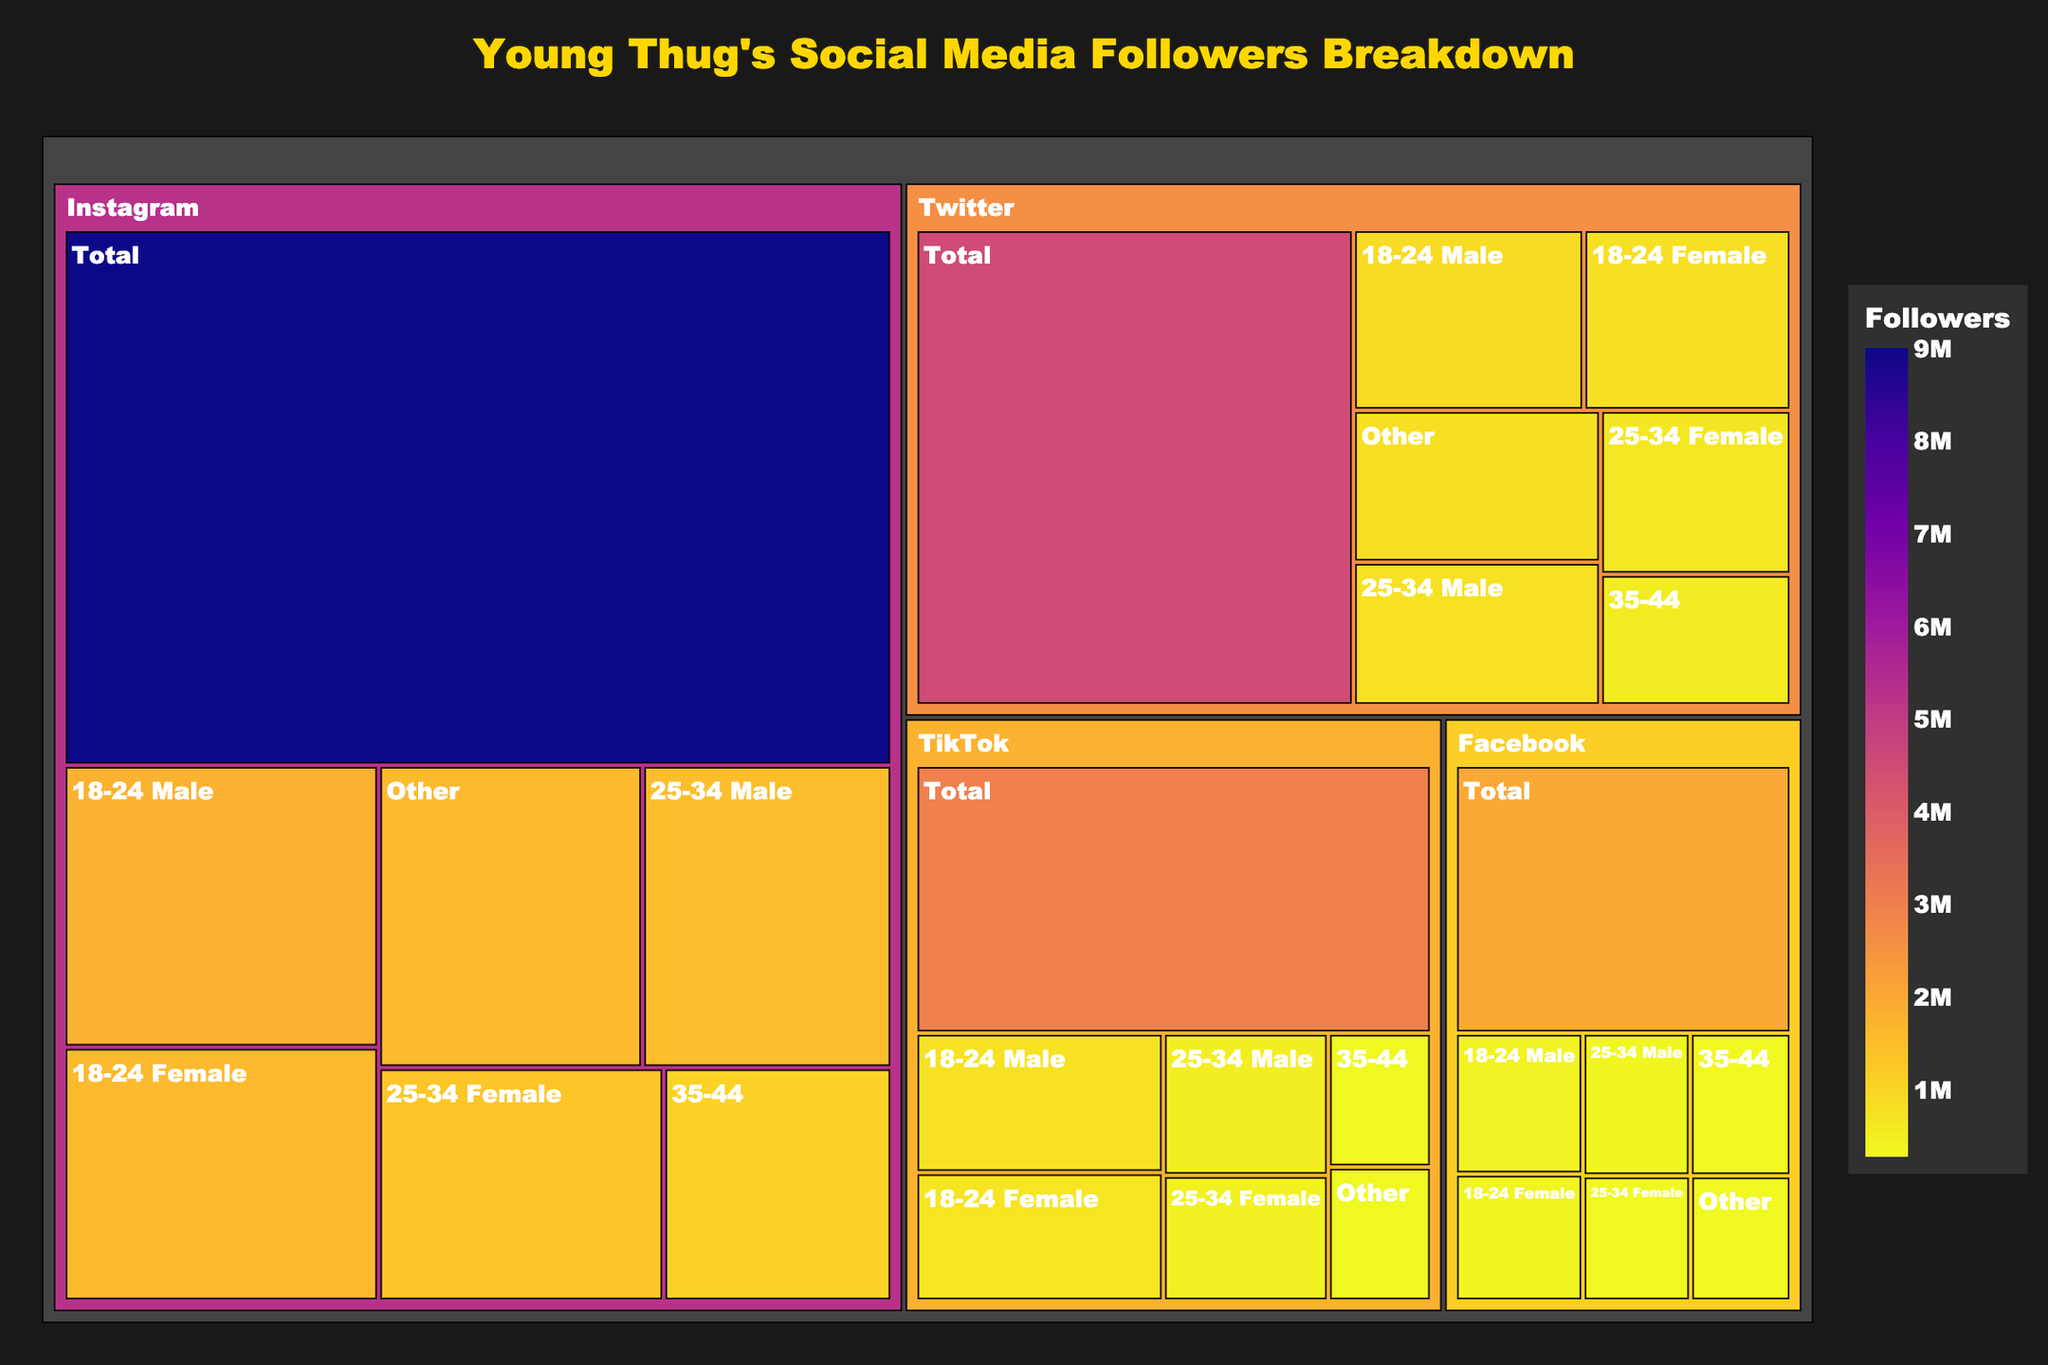What's the total number of followers on Instagram? The treemap shows a category for total followers on each platform. Find the "Instagram" category and look for the "Total" subcategory, which displays 9,000,000 followers.
Answer: 9 million What's the number of followers in the 25-34 Female category on TikTok? Locate the TikTok category in the treemap, then find the "25-34 Female" subcategory, which displays 450,000 followers.
Answer: 450,000 How many more followers does Instagram have compared to Facebook? Instagram's total followers: 9,000,000. Facebook's total followers: 2,000,000. Subtract Facebook's total from Instagram's total: 9,000,000 - 2,000,000 = 7,000,000.
Answer: 7 million Which platform has the fewest total followers? Examine the total follower counts for all platforms. Facebook has the fewest with 2,000,000 followers.
Answer: Facebook What is the combined number of Twitter followers in the 25-34 age range? Twitter's followers for 25-34 Male: 765,000. Twitter's followers for 25-34 Female: 675,000. Add these two numbers: 765,000 + 675,000 = 1,440,000.
Answer: 1.44 million How does the number of male followers in the 18-24 age group compare across platforms? Check the 18-24 Male subcategory for each platform:
- Instagram: 1,800,000
- Twitter: 900,000
- TikTok: 750,000
- Facebook: 400,000.
Instagram has the most, followed by Twitter, TikTok, and Facebook.
Answer: Instagram > Twitter > TikTok > Facebook Which demographic has the highest number of followers on any platform? Look for the subcategory with the highest follower count across all platforms. It is "Total" on Instagram with 9,000,000 followers.
Answer: Instagram Total What's the percentage of "Other" followers on Instagram out of the total Instagram followers? Instagram's "Other" followers: 1,620,000. Total followers: 9,000,000. Calculate the percentage: (1,620,000/9,000,000) * 100 ≈ 18%.
Answer: 18% What's the sum of followers in the 35-44 category across all platforms? Sum the 35-44 followers for each platform:
- Instagram: 1,080,000
- Twitter: 540,000
- TikTok: 300,000
- Facebook: 320,000.
Total: 1,080,000 + 540,000 + 300,000 + 320,000 = 2,240,000.
Answer: 2.24 million 